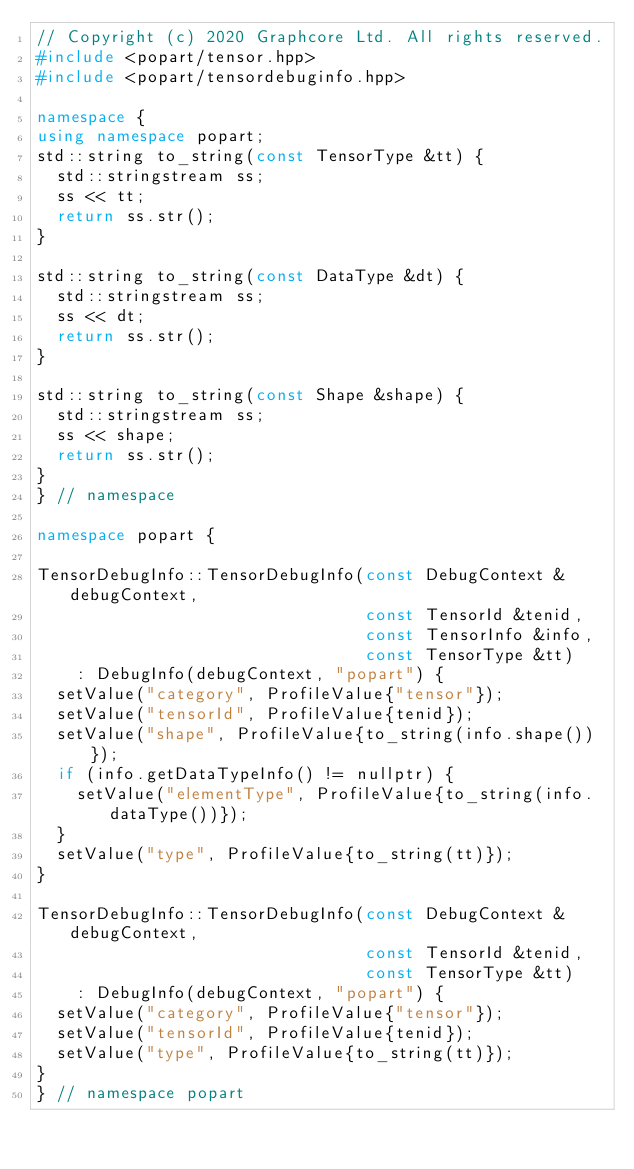Convert code to text. <code><loc_0><loc_0><loc_500><loc_500><_C++_>// Copyright (c) 2020 Graphcore Ltd. All rights reserved.
#include <popart/tensor.hpp>
#include <popart/tensordebuginfo.hpp>

namespace {
using namespace popart;
std::string to_string(const TensorType &tt) {
  std::stringstream ss;
  ss << tt;
  return ss.str();
}

std::string to_string(const DataType &dt) {
  std::stringstream ss;
  ss << dt;
  return ss.str();
}

std::string to_string(const Shape &shape) {
  std::stringstream ss;
  ss << shape;
  return ss.str();
}
} // namespace

namespace popart {

TensorDebugInfo::TensorDebugInfo(const DebugContext &debugContext,
                                 const TensorId &tenid,
                                 const TensorInfo &info,
                                 const TensorType &tt)
    : DebugInfo(debugContext, "popart") {
  setValue("category", ProfileValue{"tensor"});
  setValue("tensorId", ProfileValue{tenid});
  setValue("shape", ProfileValue{to_string(info.shape())});
  if (info.getDataTypeInfo() != nullptr) {
    setValue("elementType", ProfileValue{to_string(info.dataType())});
  }
  setValue("type", ProfileValue{to_string(tt)});
}

TensorDebugInfo::TensorDebugInfo(const DebugContext &debugContext,
                                 const TensorId &tenid,
                                 const TensorType &tt)
    : DebugInfo(debugContext, "popart") {
  setValue("category", ProfileValue{"tensor"});
  setValue("tensorId", ProfileValue{tenid});
  setValue("type", ProfileValue{to_string(tt)});
}
} // namespace popart</code> 